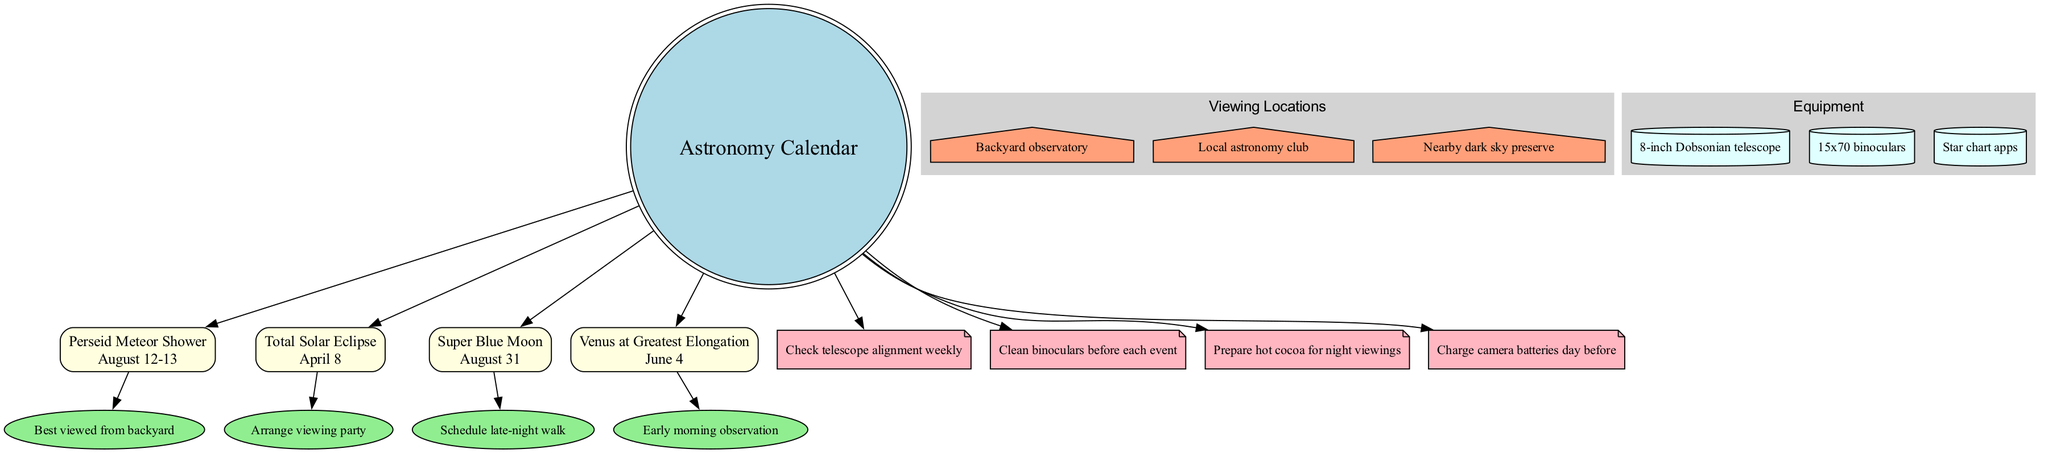What is the date of the Total Solar Eclipse? The diagram clearly indicates that the date for the Total Solar Eclipse event is "April 8" listed under the event box.
Answer: April 8 How many events are highlighted in the diagram? By counting the event nodes connected to the center node, we find there are four events: Perseid Meteor Shower, Total Solar Eclipse, Super Blue Moon, and Venus at Greatest Elongation.
Answer: 4 What location is listed for backyard astronomy? The diagram specifies "Backyard observatory" as one of the possible viewing locations, directly linked to the center.
Answer: Backyard observatory Which event has the observation instructions to prepare a viewing party? The description provided for the Total Solar Eclipse event explicitly suggests to "Arrange viewing party," making it clear this is related to that event.
Answer: Total Solar Eclipse What equipment should be checked weekly? The reminders section indicates "Check telescope alignment weekly," which advises on maintaining equipment for optimal performance.
Answer: Telescope Which event occurs on August 31? The diagram identifies the "Super Blue Moon" as occurring on August 31, clearly mentioned in the event section.
Answer: Super Blue Moon How many reminders are in the diagram? Counting the reminder nodes linked to the center, we note there are four reminders explicitly outlined in the diagram.
Answer: 4 What type of telescope is listed as equipment? The diagram lists an "8-inch Dobsonian telescope" under the equipment section, clearly defined in the relevant node.
Answer: 8-inch Dobsonian telescope What celestial event can be observed in the early morning of June 4? The event node for "Venus at Greatest Elongation" indicates it is to be observed in the early morning, providing specific timing instructions.
Answer: Venus at Greatest Elongation 